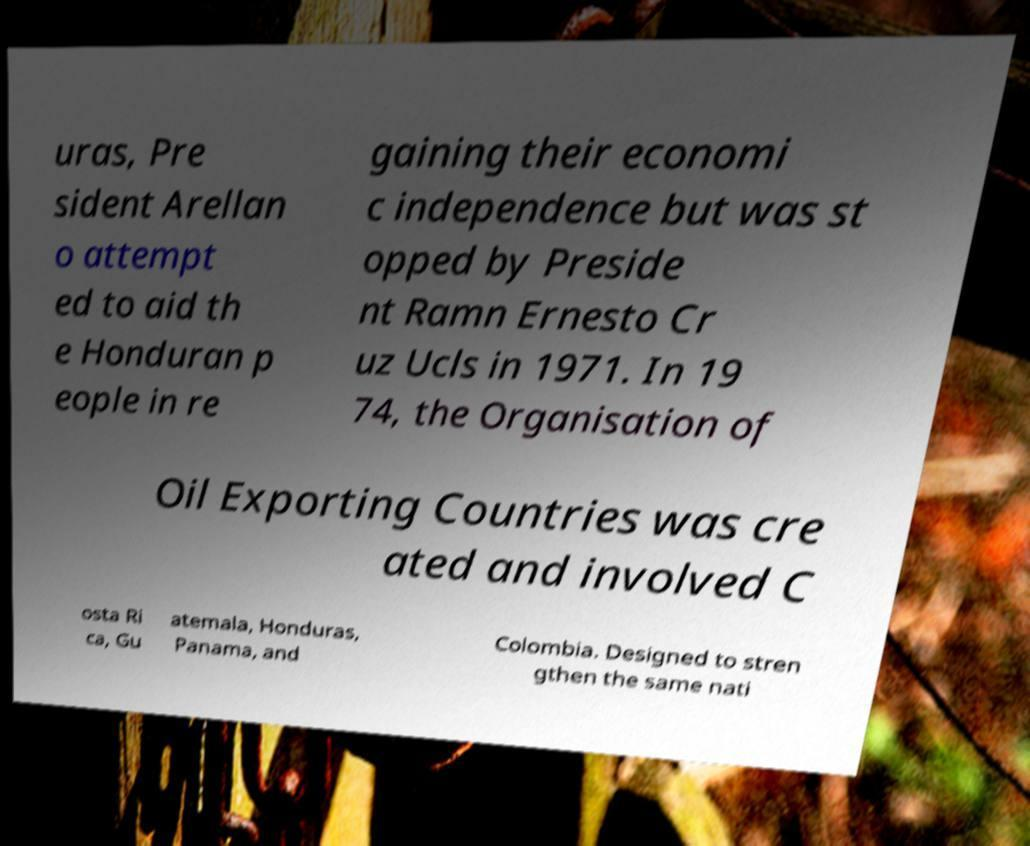Could you assist in decoding the text presented in this image and type it out clearly? uras, Pre sident Arellan o attempt ed to aid th e Honduran p eople in re gaining their economi c independence but was st opped by Preside nt Ramn Ernesto Cr uz Ucls in 1971. In 19 74, the Organisation of Oil Exporting Countries was cre ated and involved C osta Ri ca, Gu atemala, Honduras, Panama, and Colombia. Designed to stren gthen the same nati 